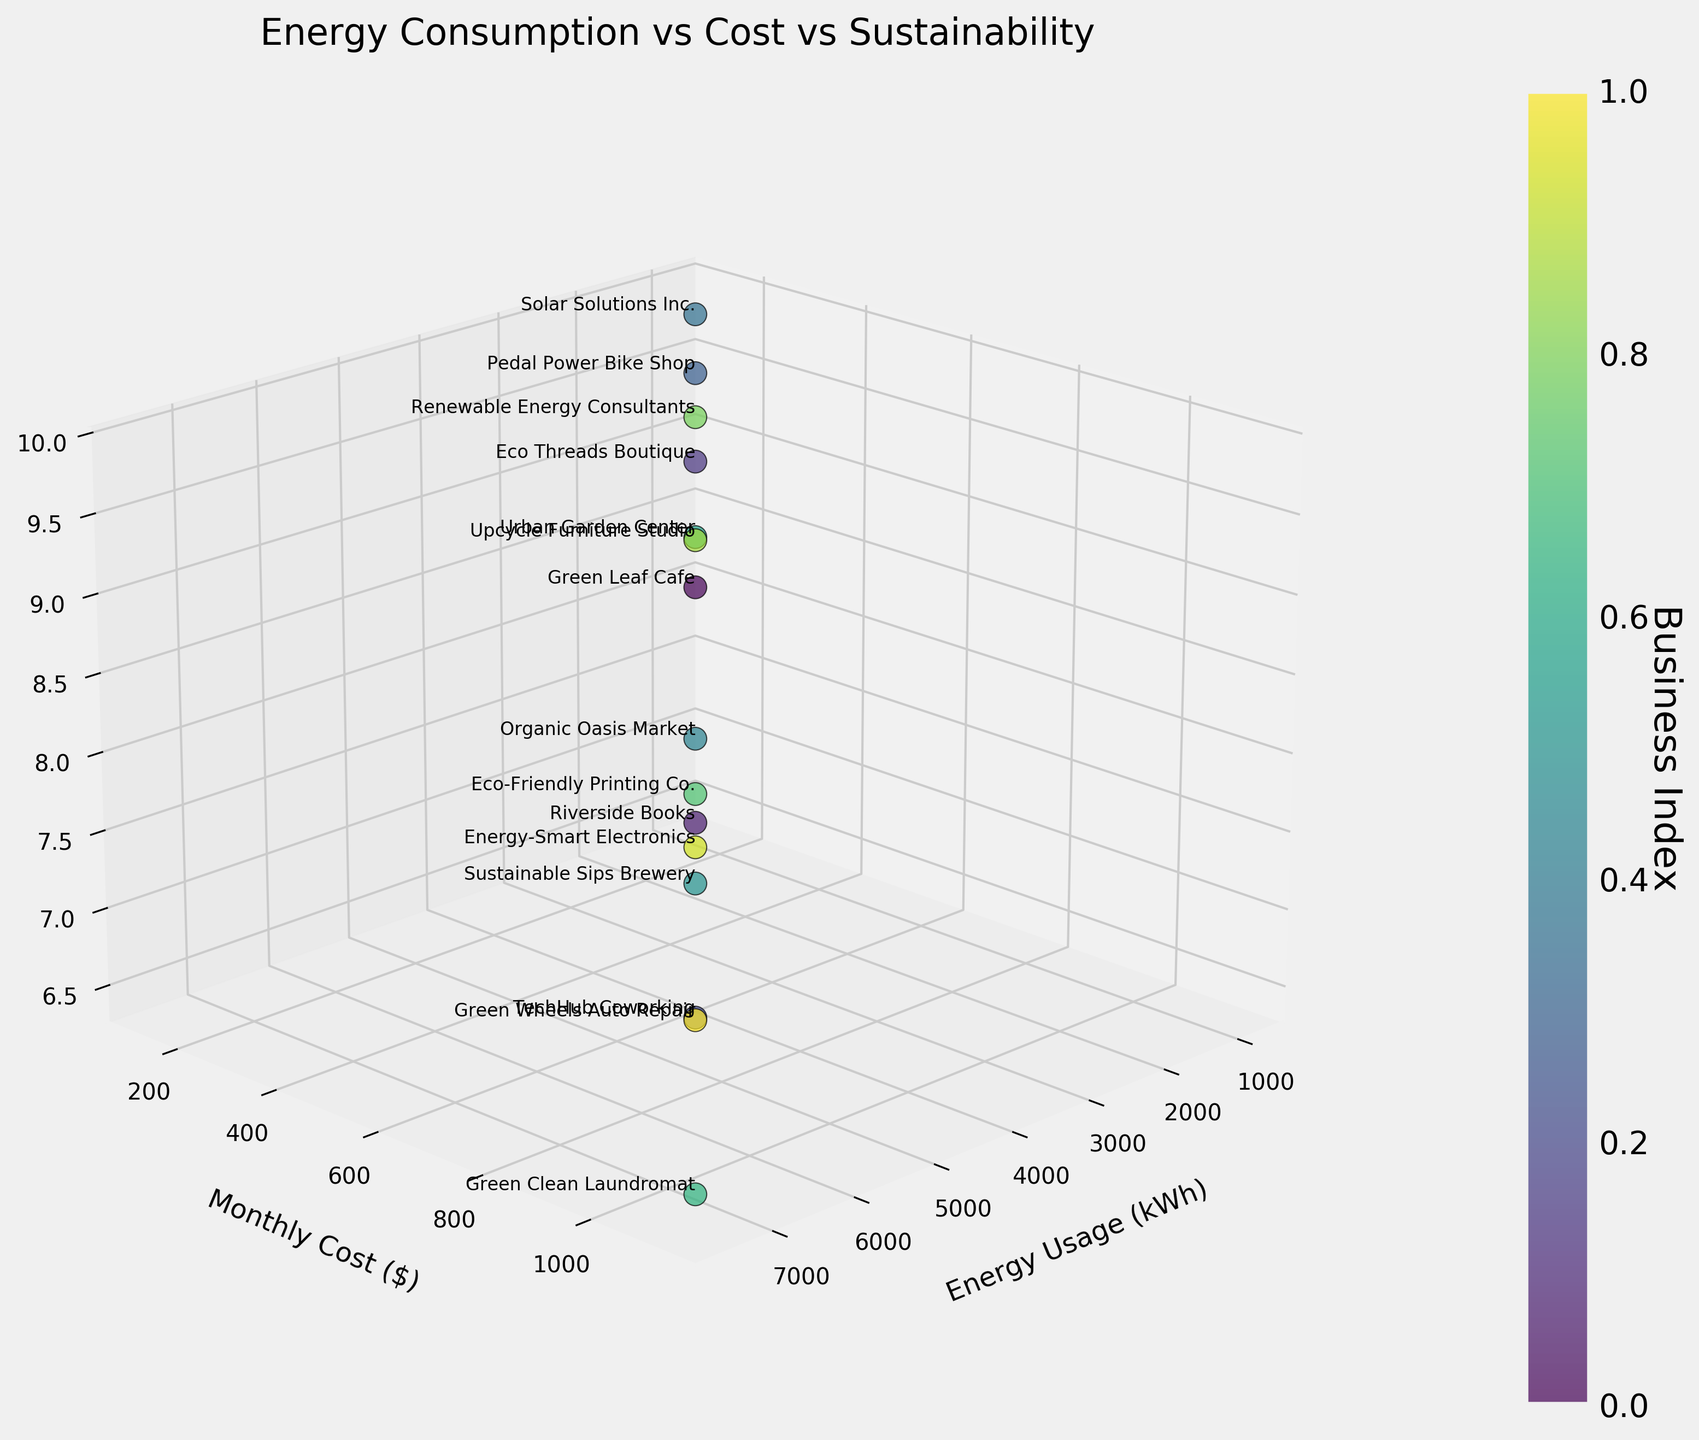How many businesses are plotted in the figure? By counting the number of unique data points identified by business names, we conclude that there are 15 businesses plotted.
Answer: 15 Which business has the highest energy usage? The 3D scatter plot can be inspected to identify the point furthest along the `Energy Usage (kWh)` axis. The business with the highest usage is "Green Clean Laundromat" with 7500 kWh.
Answer: Green Clean Laundromat Which business has the highest sustainability score and what is their score? By examining the plot for the point that is highest along the `Sustainability Score` axis, it is evident that "Solar Solutions Inc." has the highest score, with a value of 9.8.
Answer: Solar Solutions Inc., 9.8 Is there a general trend between energy usage and monthly cost? By observing the distribution of data points, it appears that businesses with higher energy usage tend to have higher monthly costs, indicating a positive correlation between energy usage and monthly cost.
Answer: Positive correlation Which business has the lowest monthly cost and what is it? By finding the point lowest along the `Monthly Cost ($)` axis, the business "Solar Solutions Inc." has the lowest monthly cost, which is $135.
Answer: Solar Solutions Inc., $135 Among businesses with sustainability scores above 9.0, which one has the highest energy usage? Filter the points with sustainability scores above 9.0 and then check their energy usage values. "Eco Threads Boutique" has the highest energy usage in this group with 1800 kWh.
Answer: Eco Threads Boutique Compare the monthly costs of "TechHub Coworking" and "Green Wheels Auto Repair." Which one is more expensive? Identify the points for "TechHub Coworking" and "Green Wheels Auto Repair" and compare their `Monthly Cost ($)` values. "Green Wheels Auto Repair" has a monthly cost of $870, while "TechHub Coworking" has $825, making "Green Wheels Auto Repair" more expensive.
Answer: Green Wheels Auto Repair Which business has a sustainability score of exactly 8.5? Locate the point corresponding to a `Sustainability Score` of 8.5. The business is "Green Leaf Cafe".
Answer: Green Leaf Cafe Are there any businesses with the same monthly cost but different sustainability scores? Examining the data points for businesses with matching `Monthly Cost ($)` values but different `Sustainability Scores`, there are no such businesses in this dataset.
Answer: No 